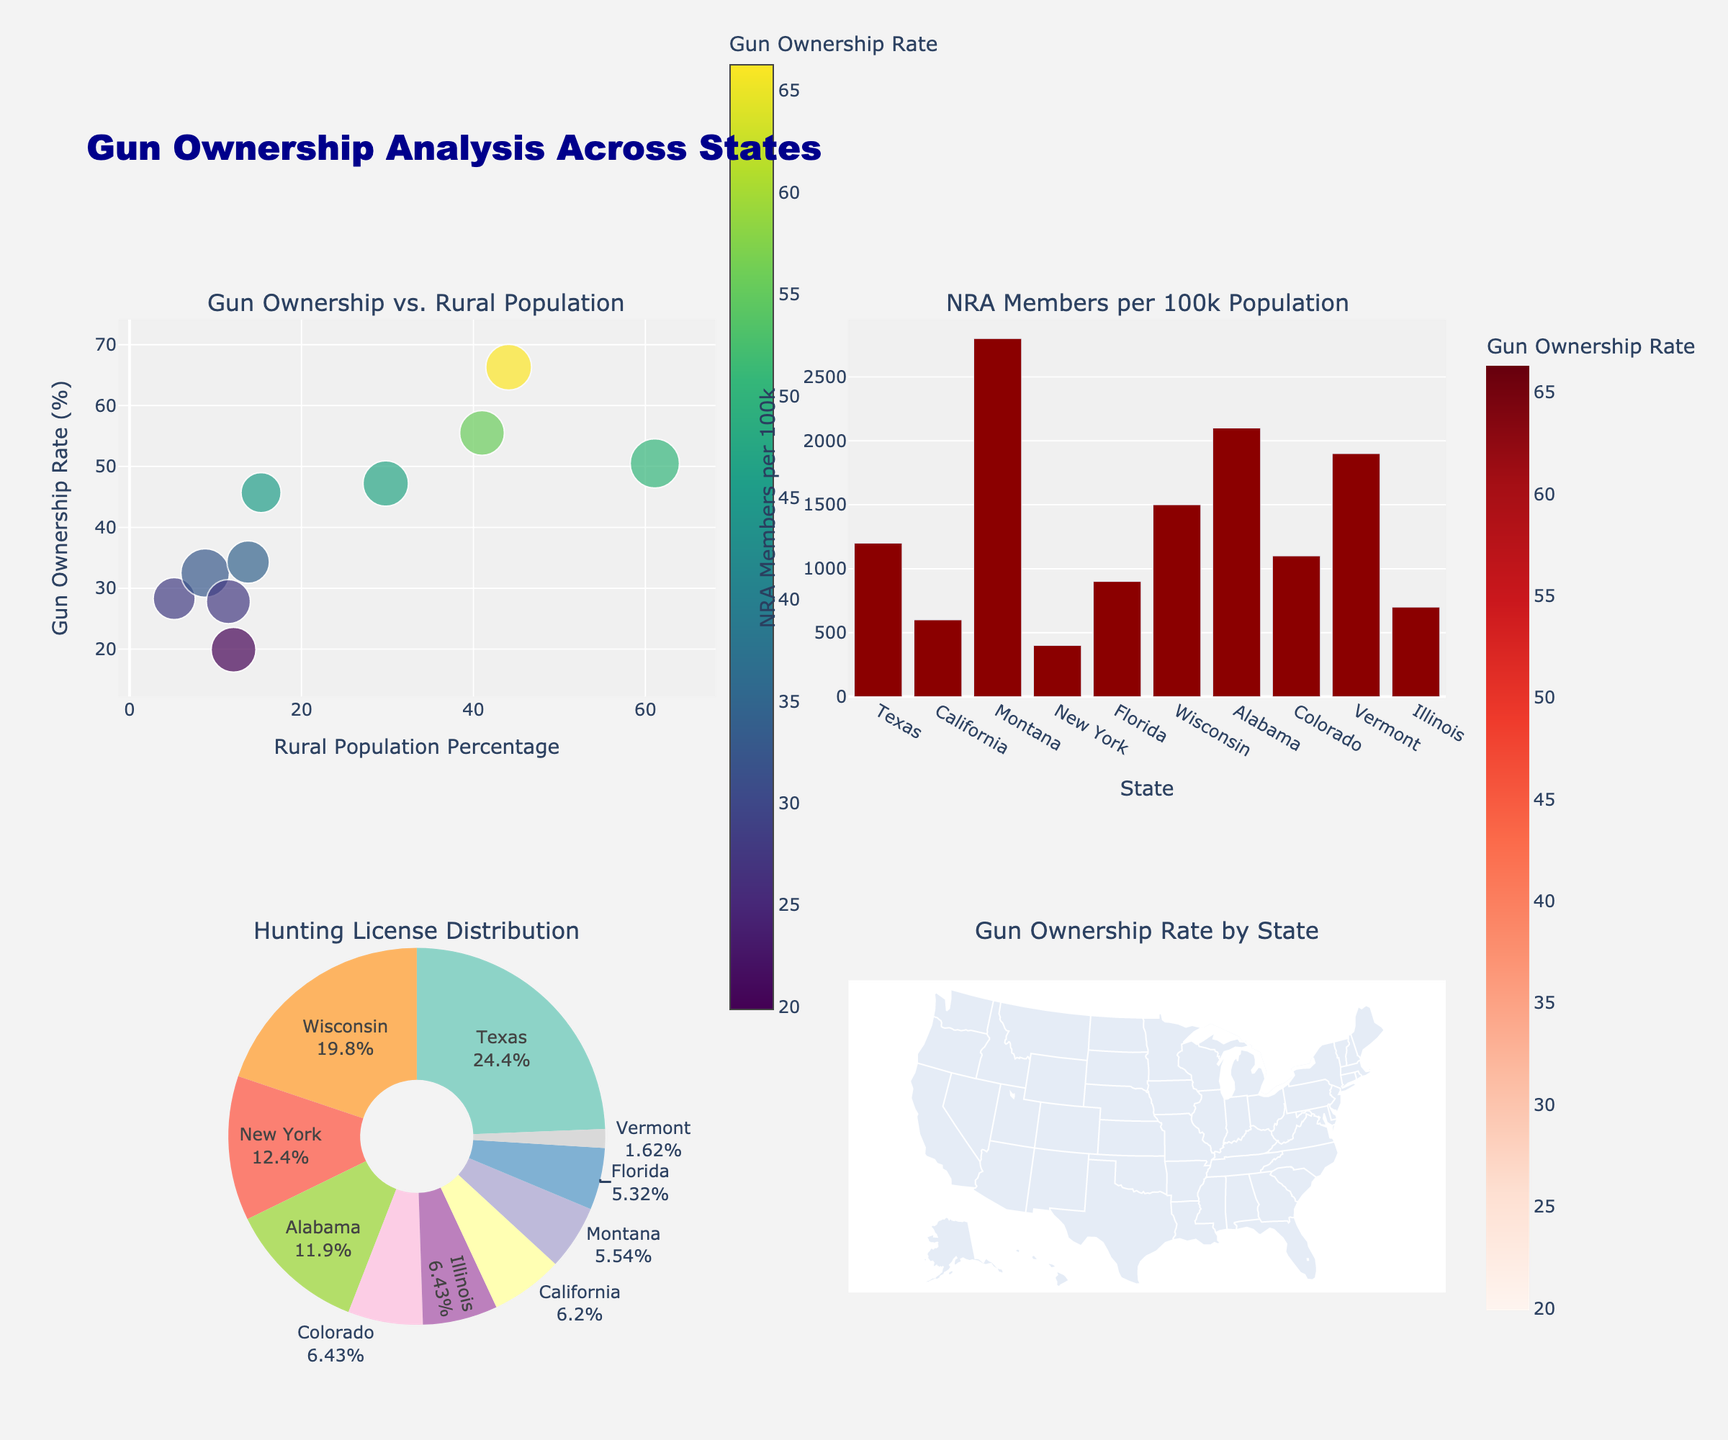Which couple's grave receives the highest number of visitors in July? By examining the subplot for July, we can see that Romeo and Juliet have the highest peak compared to the other subplots.
Answer: Romeo and Juliet Which couple has the lowest visitor count in February? Compare the February data points across all subplots. Tristan and Isolde have the lowest visitor count in this month.
Answer: Tristan and Isolde What is the general trend of visitors to Antony and Cleopatra's grave from January to August? Observing the Antony and Cleopatra subplot, the visitor count generally increases consistently each month from January to August.
Answer: Increasing trend How does the count of visitors in May compare between Romeo and Juliet and Antony and Cleopatra? Examine the May data points in the subplots of Romeo and Juliet as well as Antony and Cleopatra, and compare the values. Romeo and Juliet have more visitors in May.
Answer: Romeo and Juliet have more What is the difference in visitor count between Abelard and Heloise and Tristan and Isolde in March? Subtract the visitor count of Tristan and Isolde from that of Abelard and Heloise for the month of March. 1200 - 900 = 300.
Answer: 300 Which couple experiences the greatest increase in visitors from January to February? Calculate the increase for each couple by subtracting January counts from February. Romeo and Juliet have the highest increase (2500 - 1200 = 1300).
Answer: Romeo and Juliet What is the average number of visitors for Tristan and Isolde over the entire year? Sum all the monthly visitor counts for Tristan and Isolde and divide by 12 (600 + 1400 + 900 + 1200 + 1800 + 2200 + 2400 + 2600 + 2000 + 1600 + 1000 + 800 = 18500; 18500 / 12 ≈ 1541.67).
Answer: 1541.67 When comparing the visitor trends for May and June, which couple shows a significant increase? Compare the May and June data points for each subplot. All couples show an increase, but Romeo and Juliet have the most significant rise (700).
Answer: Romeo and Juliet What is the total number of visitors for all couples in September? Sum the visitor counts for all couples in September (3200 + 2400 + 2000 + 2800 = 10400).
Answer: 10400 Do visitor counts show any seasonal patterns, such as higher in some months and lower in others? Looking at all subplots collectively, there is an evident seasonal pattern: visitor counts generally increase during spring and summer (March to August) and decrease during autumn and winter (September to February).
Answer: Yes, there is a seasonal pattern 